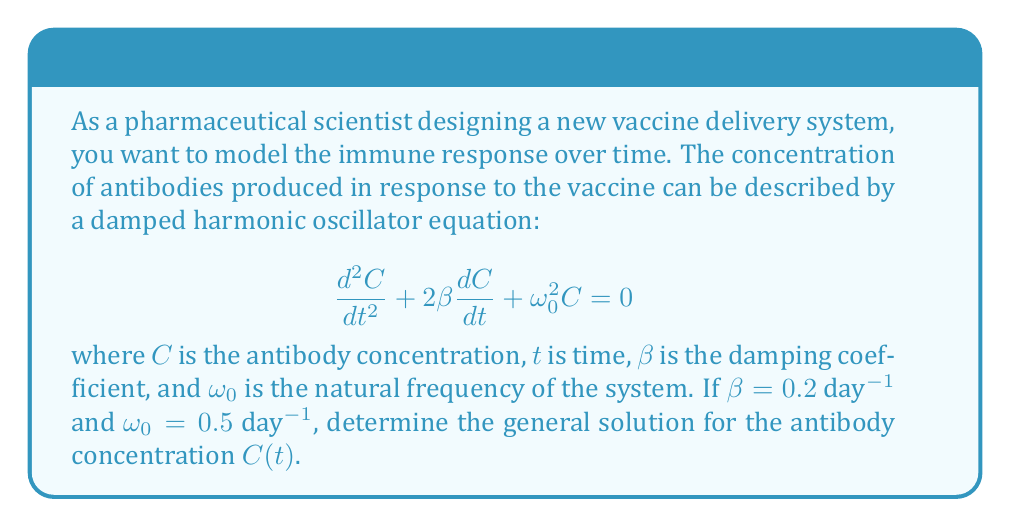What is the answer to this math problem? To solve this second-order linear differential equation, we follow these steps:

1) First, we need to determine the characteristic equation:
   $$r^2 + 2\beta r + \omega_0^2 = 0$$

2) Substituting the given values:
   $$r^2 + 2(0.2)r + 0.5^2 = 0$$
   $$r^2 + 0.4r + 0.25 = 0$$

3) We can solve this quadratic equation using the quadratic formula:
   $$r = \frac{-b \pm \sqrt{b^2 - 4ac}}{2a}$$
   where $a=1$, $b=0.4$, and $c=0.25$

4) Calculating:
   $$r = \frac{-0.4 \pm \sqrt{0.4^2 - 4(1)(0.25)}}{2(1)}$$
   $$r = \frac{-0.4 \pm \sqrt{0.16 - 1}}{2}$$
   $$r = \frac{-0.4 \pm \sqrt{-0.84}}{2}$$
   $$r = -0.2 \pm 0.458i$$

5) Since we have complex roots, the solution will be in the form of damped oscillations:
   $$C(t) = e^{-0.2t}(A\cos(0.458t) + B\sin(0.458t))$$

   where $A$ and $B$ are constants determined by initial conditions.

This solution represents a damped oscillatory response, which is typical for vaccine-induced antibody production. The exponential term $e^{-0.2t}$ causes the oscillations to decay over time, reflecting the gradual decrease in antibody levels after vaccination.
Answer: The general solution for the antibody concentration is:

$$C(t) = e^{-0.2t}(A\cos(0.458t) + B\sin(0.458t))$$

where $A$ and $B$ are constants determined by initial conditions. 